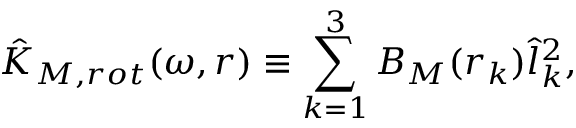<formula> <loc_0><loc_0><loc_500><loc_500>\hat { K } _ { M , r o t } ( \omega , r ) \equiv \sum _ { k = 1 } ^ { 3 } B _ { M } ( r _ { k } ) \hat { l } _ { k } ^ { 2 } ,</formula> 